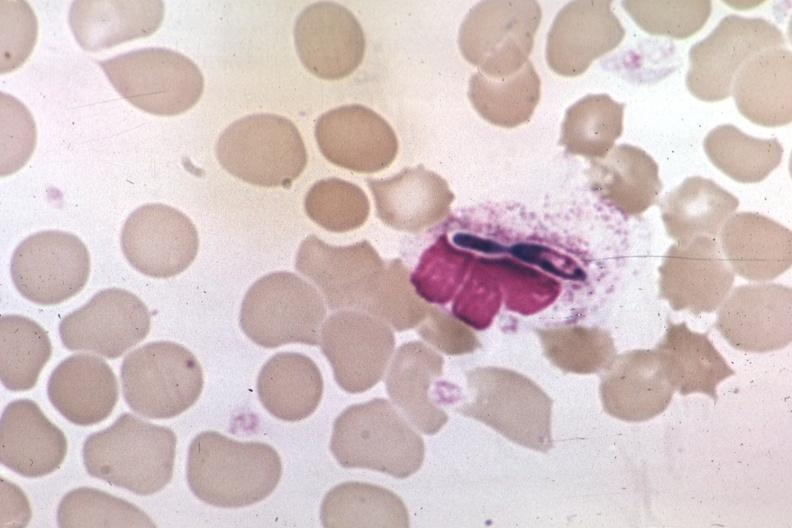what is present?
Answer the question using a single word or phrase. Blood 